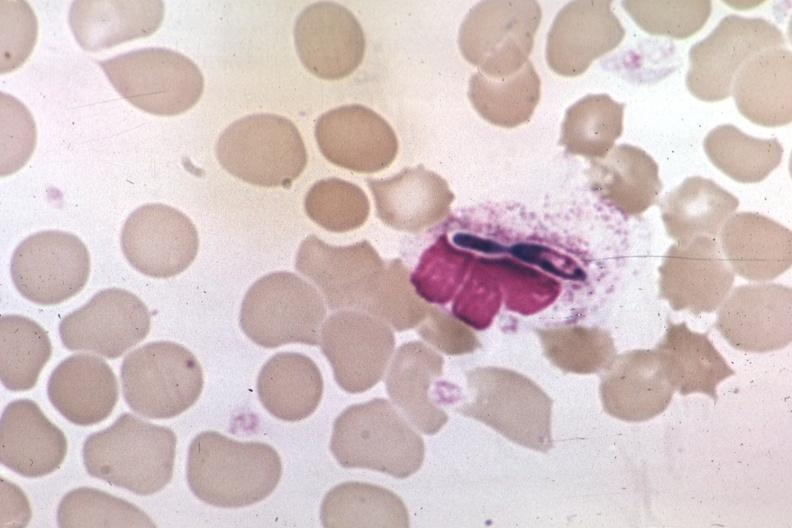what is present?
Answer the question using a single word or phrase. Blood 